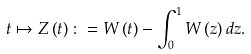<formula> <loc_0><loc_0><loc_500><loc_500>t \mapsto Z \left ( t \right ) \colon = W \left ( t \right ) - \int _ { 0 } ^ { 1 } W \left ( z \right ) d z .</formula> 